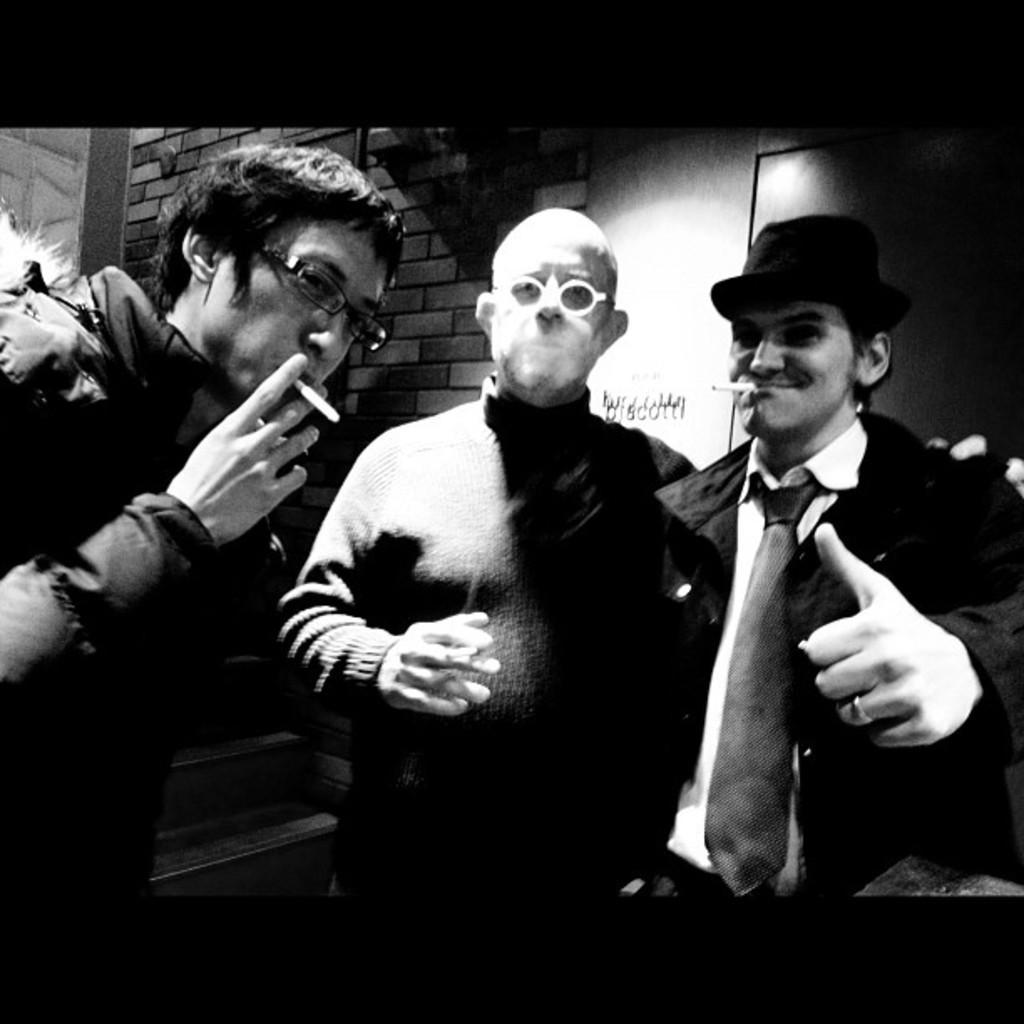In one or two sentences, can you explain what this image depicts? In this image we can see three persons and the persons are smoking. Behind the persons we can see a wall. 